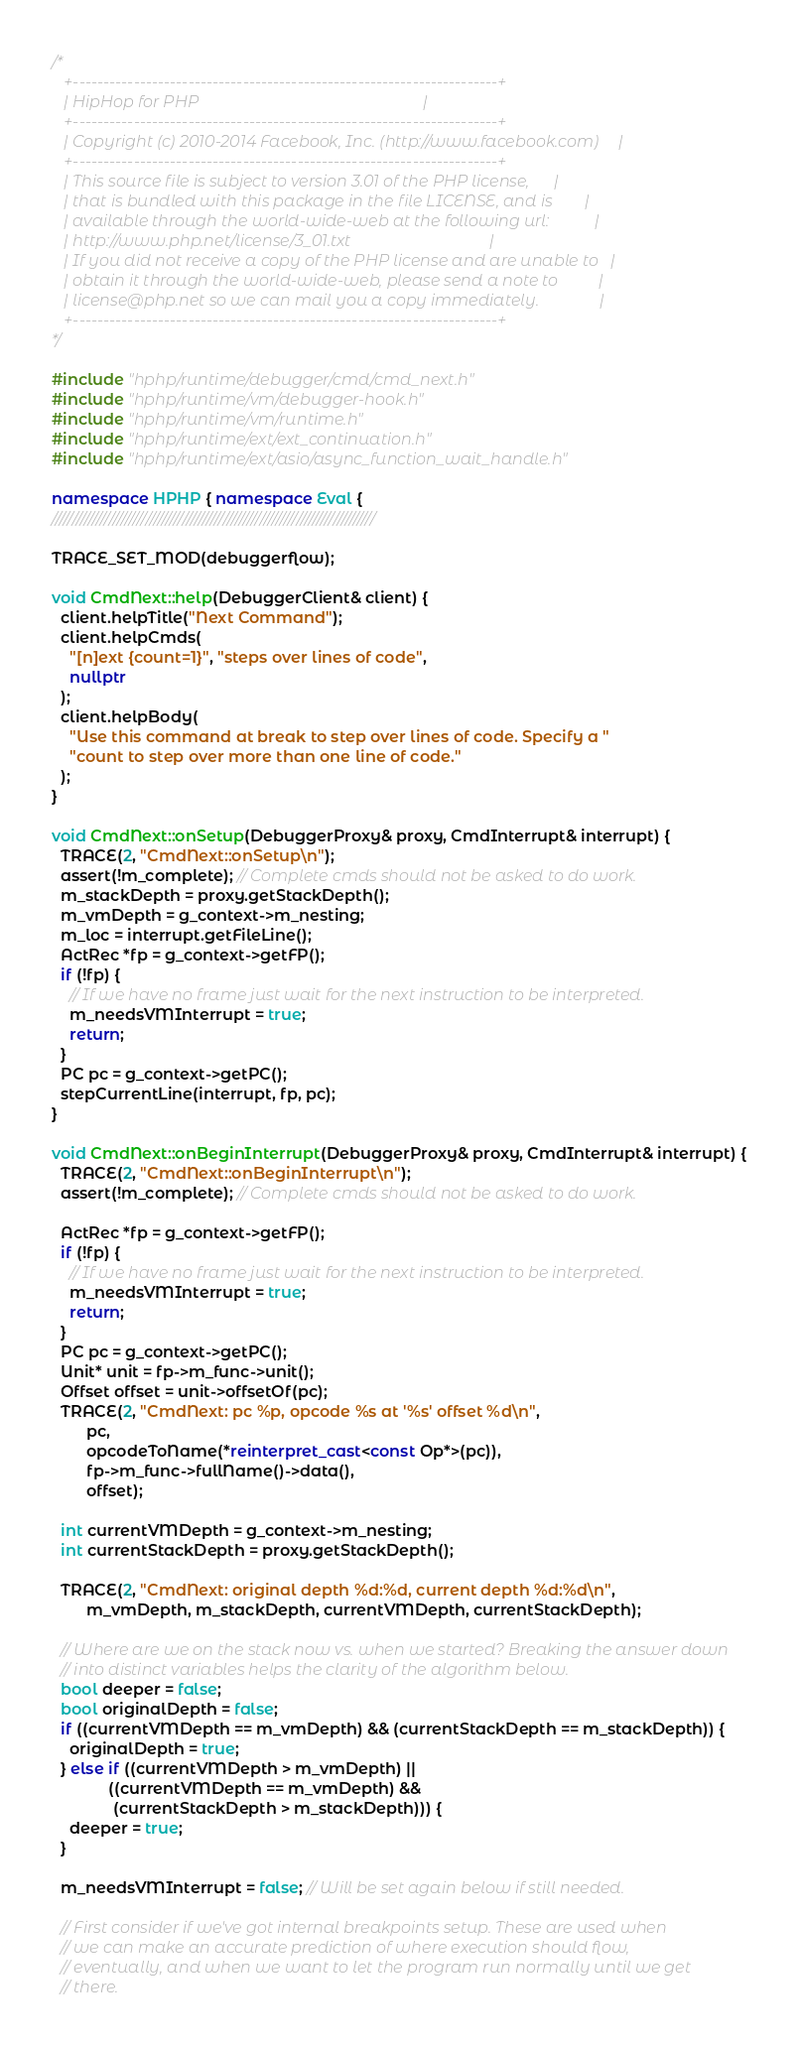<code> <loc_0><loc_0><loc_500><loc_500><_C++_>/*
   +----------------------------------------------------------------------+
   | HipHop for PHP                                                       |
   +----------------------------------------------------------------------+
   | Copyright (c) 2010-2014 Facebook, Inc. (http://www.facebook.com)     |
   +----------------------------------------------------------------------+
   | This source file is subject to version 3.01 of the PHP license,      |
   | that is bundled with this package in the file LICENSE, and is        |
   | available through the world-wide-web at the following url:           |
   | http://www.php.net/license/3_01.txt                                  |
   | If you did not receive a copy of the PHP license and are unable to   |
   | obtain it through the world-wide-web, please send a note to          |
   | license@php.net so we can mail you a copy immediately.               |
   +----------------------------------------------------------------------+
*/

#include "hphp/runtime/debugger/cmd/cmd_next.h"
#include "hphp/runtime/vm/debugger-hook.h"
#include "hphp/runtime/vm/runtime.h"
#include "hphp/runtime/ext/ext_continuation.h"
#include "hphp/runtime/ext/asio/async_function_wait_handle.h"

namespace HPHP { namespace Eval {
///////////////////////////////////////////////////////////////////////////////

TRACE_SET_MOD(debuggerflow);

void CmdNext::help(DebuggerClient& client) {
  client.helpTitle("Next Command");
  client.helpCmds(
    "[n]ext {count=1}", "steps over lines of code",
    nullptr
  );
  client.helpBody(
    "Use this command at break to step over lines of code. Specify a "
    "count to step over more than one line of code."
  );
}

void CmdNext::onSetup(DebuggerProxy& proxy, CmdInterrupt& interrupt) {
  TRACE(2, "CmdNext::onSetup\n");
  assert(!m_complete); // Complete cmds should not be asked to do work.
  m_stackDepth = proxy.getStackDepth();
  m_vmDepth = g_context->m_nesting;
  m_loc = interrupt.getFileLine();
  ActRec *fp = g_context->getFP();
  if (!fp) {
    // If we have no frame just wait for the next instruction to be interpreted.
    m_needsVMInterrupt = true;
    return;
  }
  PC pc = g_context->getPC();
  stepCurrentLine(interrupt, fp, pc);
}

void CmdNext::onBeginInterrupt(DebuggerProxy& proxy, CmdInterrupt& interrupt) {
  TRACE(2, "CmdNext::onBeginInterrupt\n");
  assert(!m_complete); // Complete cmds should not be asked to do work.

  ActRec *fp = g_context->getFP();
  if (!fp) {
    // If we have no frame just wait for the next instruction to be interpreted.
    m_needsVMInterrupt = true;
    return;
  }
  PC pc = g_context->getPC();
  Unit* unit = fp->m_func->unit();
  Offset offset = unit->offsetOf(pc);
  TRACE(2, "CmdNext: pc %p, opcode %s at '%s' offset %d\n",
        pc,
        opcodeToName(*reinterpret_cast<const Op*>(pc)),
        fp->m_func->fullName()->data(),
        offset);

  int currentVMDepth = g_context->m_nesting;
  int currentStackDepth = proxy.getStackDepth();

  TRACE(2, "CmdNext: original depth %d:%d, current depth %d:%d\n",
        m_vmDepth, m_stackDepth, currentVMDepth, currentStackDepth);

  // Where are we on the stack now vs. when we started? Breaking the answer down
  // into distinct variables helps the clarity of the algorithm below.
  bool deeper = false;
  bool originalDepth = false;
  if ((currentVMDepth == m_vmDepth) && (currentStackDepth == m_stackDepth)) {
    originalDepth = true;
  } else if ((currentVMDepth > m_vmDepth) ||
             ((currentVMDepth == m_vmDepth) &&
              (currentStackDepth > m_stackDepth))) {
    deeper = true;
  }

  m_needsVMInterrupt = false; // Will be set again below if still needed.

  // First consider if we've got internal breakpoints setup. These are used when
  // we can make an accurate prediction of where execution should flow,
  // eventually, and when we want to let the program run normally until we get
  // there.</code> 